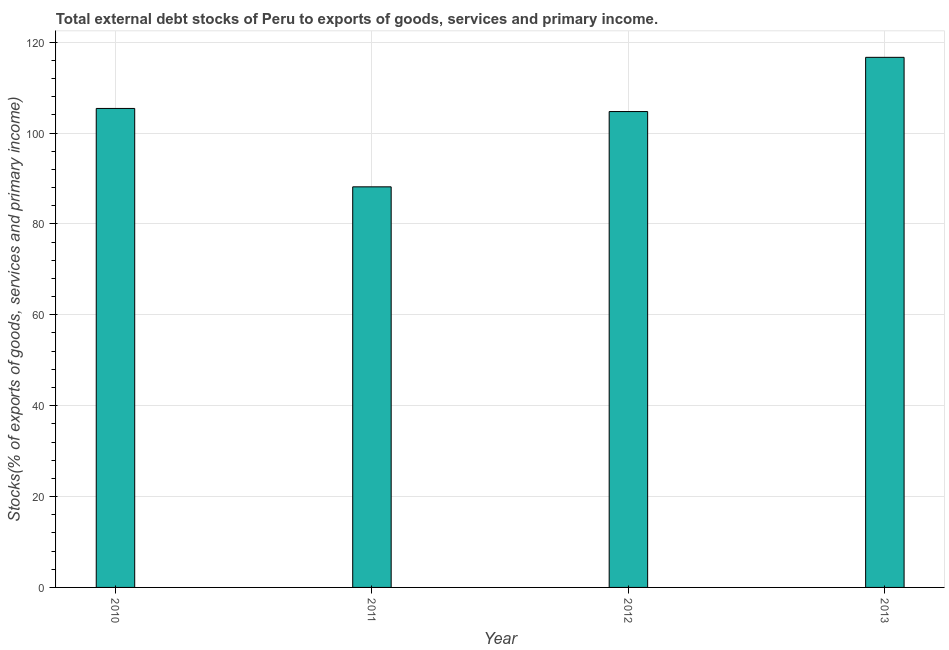What is the title of the graph?
Offer a very short reply. Total external debt stocks of Peru to exports of goods, services and primary income. What is the label or title of the X-axis?
Give a very brief answer. Year. What is the label or title of the Y-axis?
Your answer should be compact. Stocks(% of exports of goods, services and primary income). What is the external debt stocks in 2011?
Provide a short and direct response. 88.17. Across all years, what is the maximum external debt stocks?
Your answer should be very brief. 116.67. Across all years, what is the minimum external debt stocks?
Provide a short and direct response. 88.17. In which year was the external debt stocks maximum?
Offer a very short reply. 2013. What is the sum of the external debt stocks?
Your answer should be compact. 415. What is the difference between the external debt stocks in 2011 and 2013?
Provide a succinct answer. -28.5. What is the average external debt stocks per year?
Make the answer very short. 103.75. What is the median external debt stocks?
Your answer should be very brief. 105.08. Do a majority of the years between 2011 and 2013 (inclusive) have external debt stocks greater than 108 %?
Ensure brevity in your answer.  No. What is the ratio of the external debt stocks in 2010 to that in 2011?
Offer a very short reply. 1.2. Is the difference between the external debt stocks in 2010 and 2013 greater than the difference between any two years?
Provide a short and direct response. No. What is the difference between the highest and the second highest external debt stocks?
Provide a short and direct response. 11.25. In how many years, is the external debt stocks greater than the average external debt stocks taken over all years?
Provide a succinct answer. 3. Are all the bars in the graph horizontal?
Offer a very short reply. No. How many years are there in the graph?
Ensure brevity in your answer.  4. What is the difference between two consecutive major ticks on the Y-axis?
Give a very brief answer. 20. What is the Stocks(% of exports of goods, services and primary income) in 2010?
Make the answer very short. 105.42. What is the Stocks(% of exports of goods, services and primary income) of 2011?
Make the answer very short. 88.17. What is the Stocks(% of exports of goods, services and primary income) of 2012?
Your answer should be compact. 104.74. What is the Stocks(% of exports of goods, services and primary income) of 2013?
Your answer should be very brief. 116.67. What is the difference between the Stocks(% of exports of goods, services and primary income) in 2010 and 2011?
Your answer should be compact. 17.25. What is the difference between the Stocks(% of exports of goods, services and primary income) in 2010 and 2012?
Make the answer very short. 0.68. What is the difference between the Stocks(% of exports of goods, services and primary income) in 2010 and 2013?
Keep it short and to the point. -11.25. What is the difference between the Stocks(% of exports of goods, services and primary income) in 2011 and 2012?
Your answer should be very brief. -16.57. What is the difference between the Stocks(% of exports of goods, services and primary income) in 2011 and 2013?
Give a very brief answer. -28.5. What is the difference between the Stocks(% of exports of goods, services and primary income) in 2012 and 2013?
Give a very brief answer. -11.93. What is the ratio of the Stocks(% of exports of goods, services and primary income) in 2010 to that in 2011?
Provide a short and direct response. 1.2. What is the ratio of the Stocks(% of exports of goods, services and primary income) in 2010 to that in 2013?
Offer a terse response. 0.9. What is the ratio of the Stocks(% of exports of goods, services and primary income) in 2011 to that in 2012?
Offer a terse response. 0.84. What is the ratio of the Stocks(% of exports of goods, services and primary income) in 2011 to that in 2013?
Provide a succinct answer. 0.76. What is the ratio of the Stocks(% of exports of goods, services and primary income) in 2012 to that in 2013?
Provide a short and direct response. 0.9. 